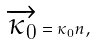Convert formula to latex. <formula><loc_0><loc_0><loc_500><loc_500>\overrightarrow { \kappa _ { 0 } } = \kappa _ { 0 } n ,</formula> 